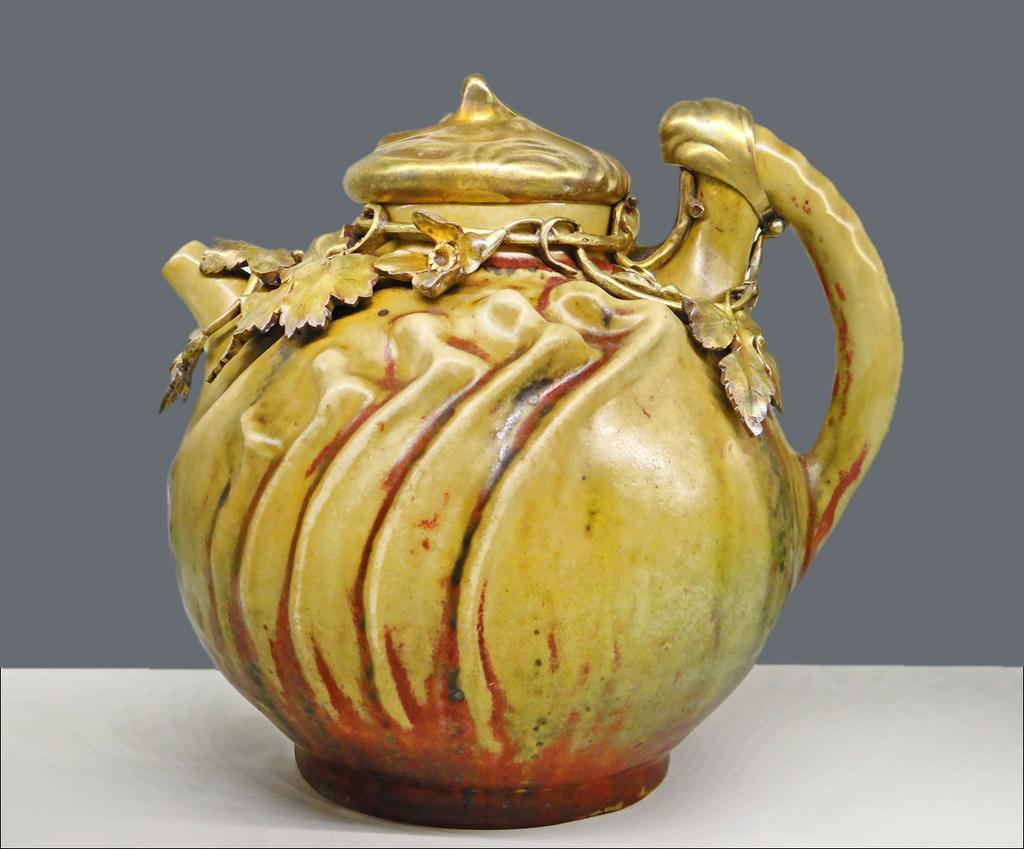What is the main object in the image? There is a kettle in the image. Where is the kettle located? The kettle is on a table. What design or pattern is present on the kettle? The kettle has structures of leaves on it. How many clocks are present on the kettle in the image? There are no clocks present on the kettle in the image. 